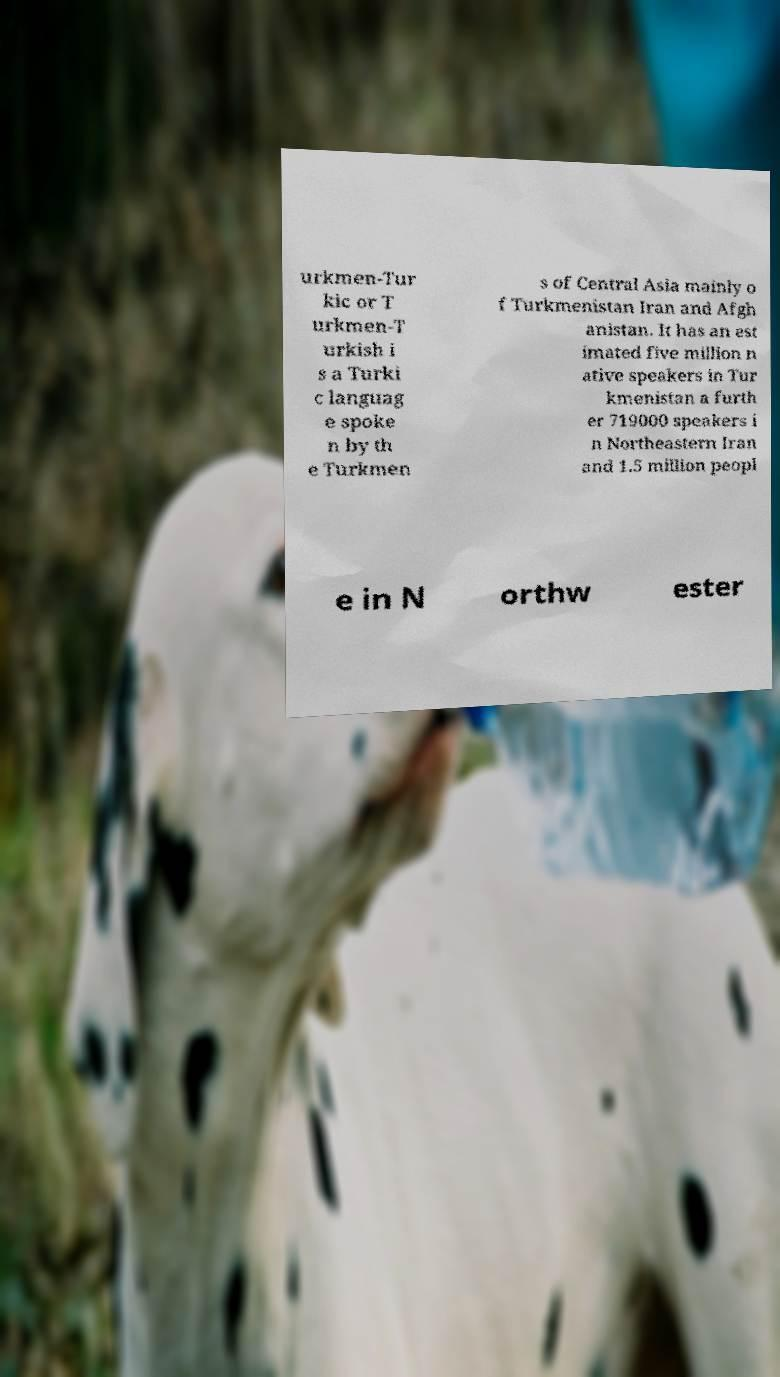Please identify and transcribe the text found in this image. urkmen-Tur kic or T urkmen-T urkish i s a Turki c languag e spoke n by th e Turkmen s of Central Asia mainly o f Turkmenistan Iran and Afgh anistan. It has an est imated five million n ative speakers in Tur kmenistan a furth er 719000 speakers i n Northeastern Iran and 1.5 million peopl e in N orthw ester 